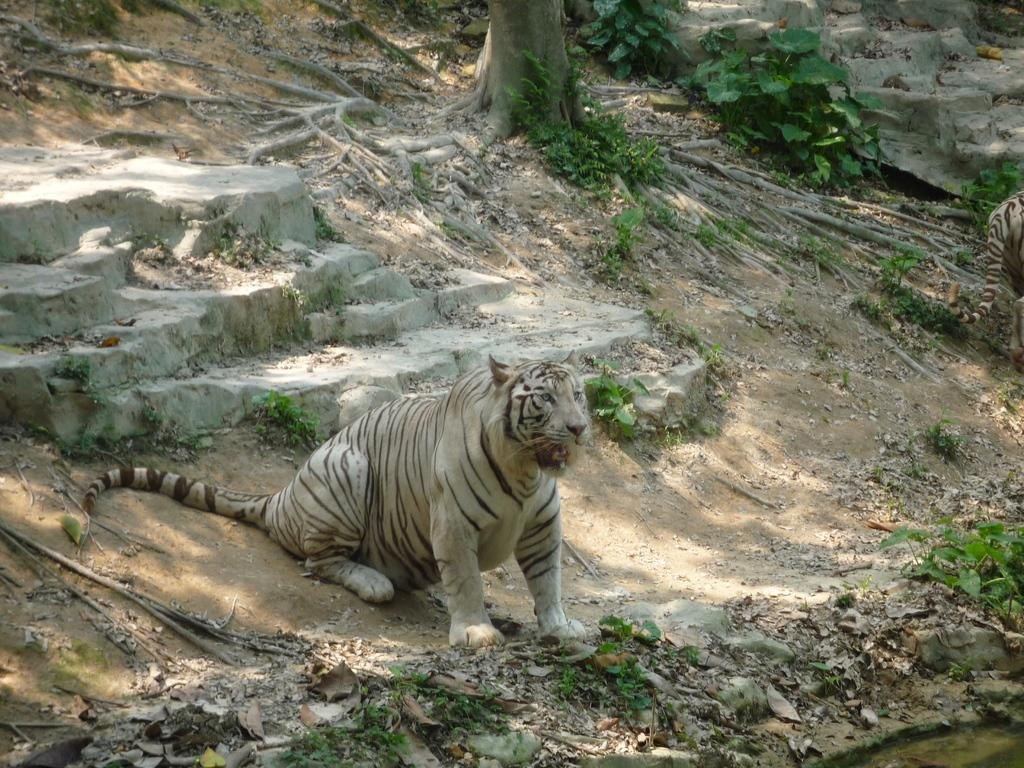What type of animal is in the image? There is a tiger in the image. What architectural feature can be seen in the image? There are stairs in the image. What natural object is present in the image? There is a tree trunk in the image. What type of vegetation is in the image? There are plants in the image. What type of star can be seen in the image? There is no star visible in the image. 